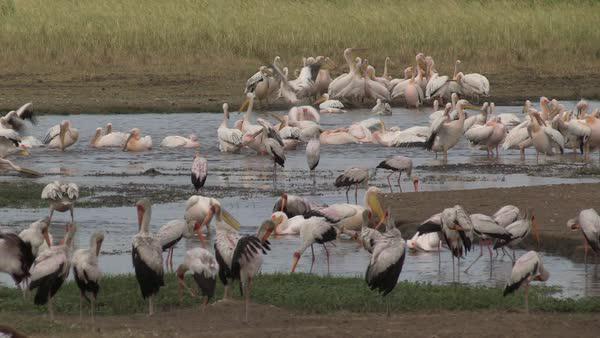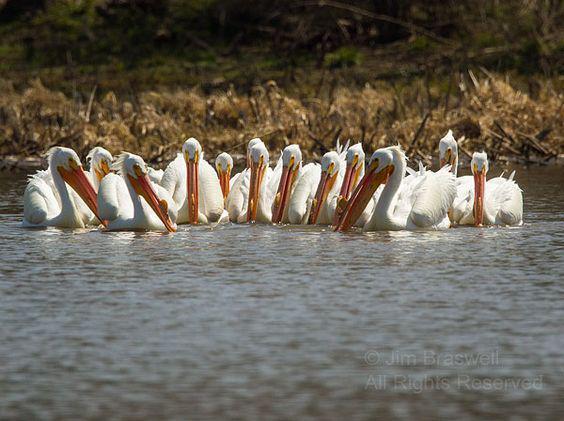The first image is the image on the left, the second image is the image on the right. Analyze the images presented: Is the assertion "An image features exactly three pelicans, all facing the same way." valid? Answer yes or no. No. The first image is the image on the left, the second image is the image on the right. Examine the images to the left and right. Is the description "The rightmost image has 3 birds." accurate? Answer yes or no. No. 